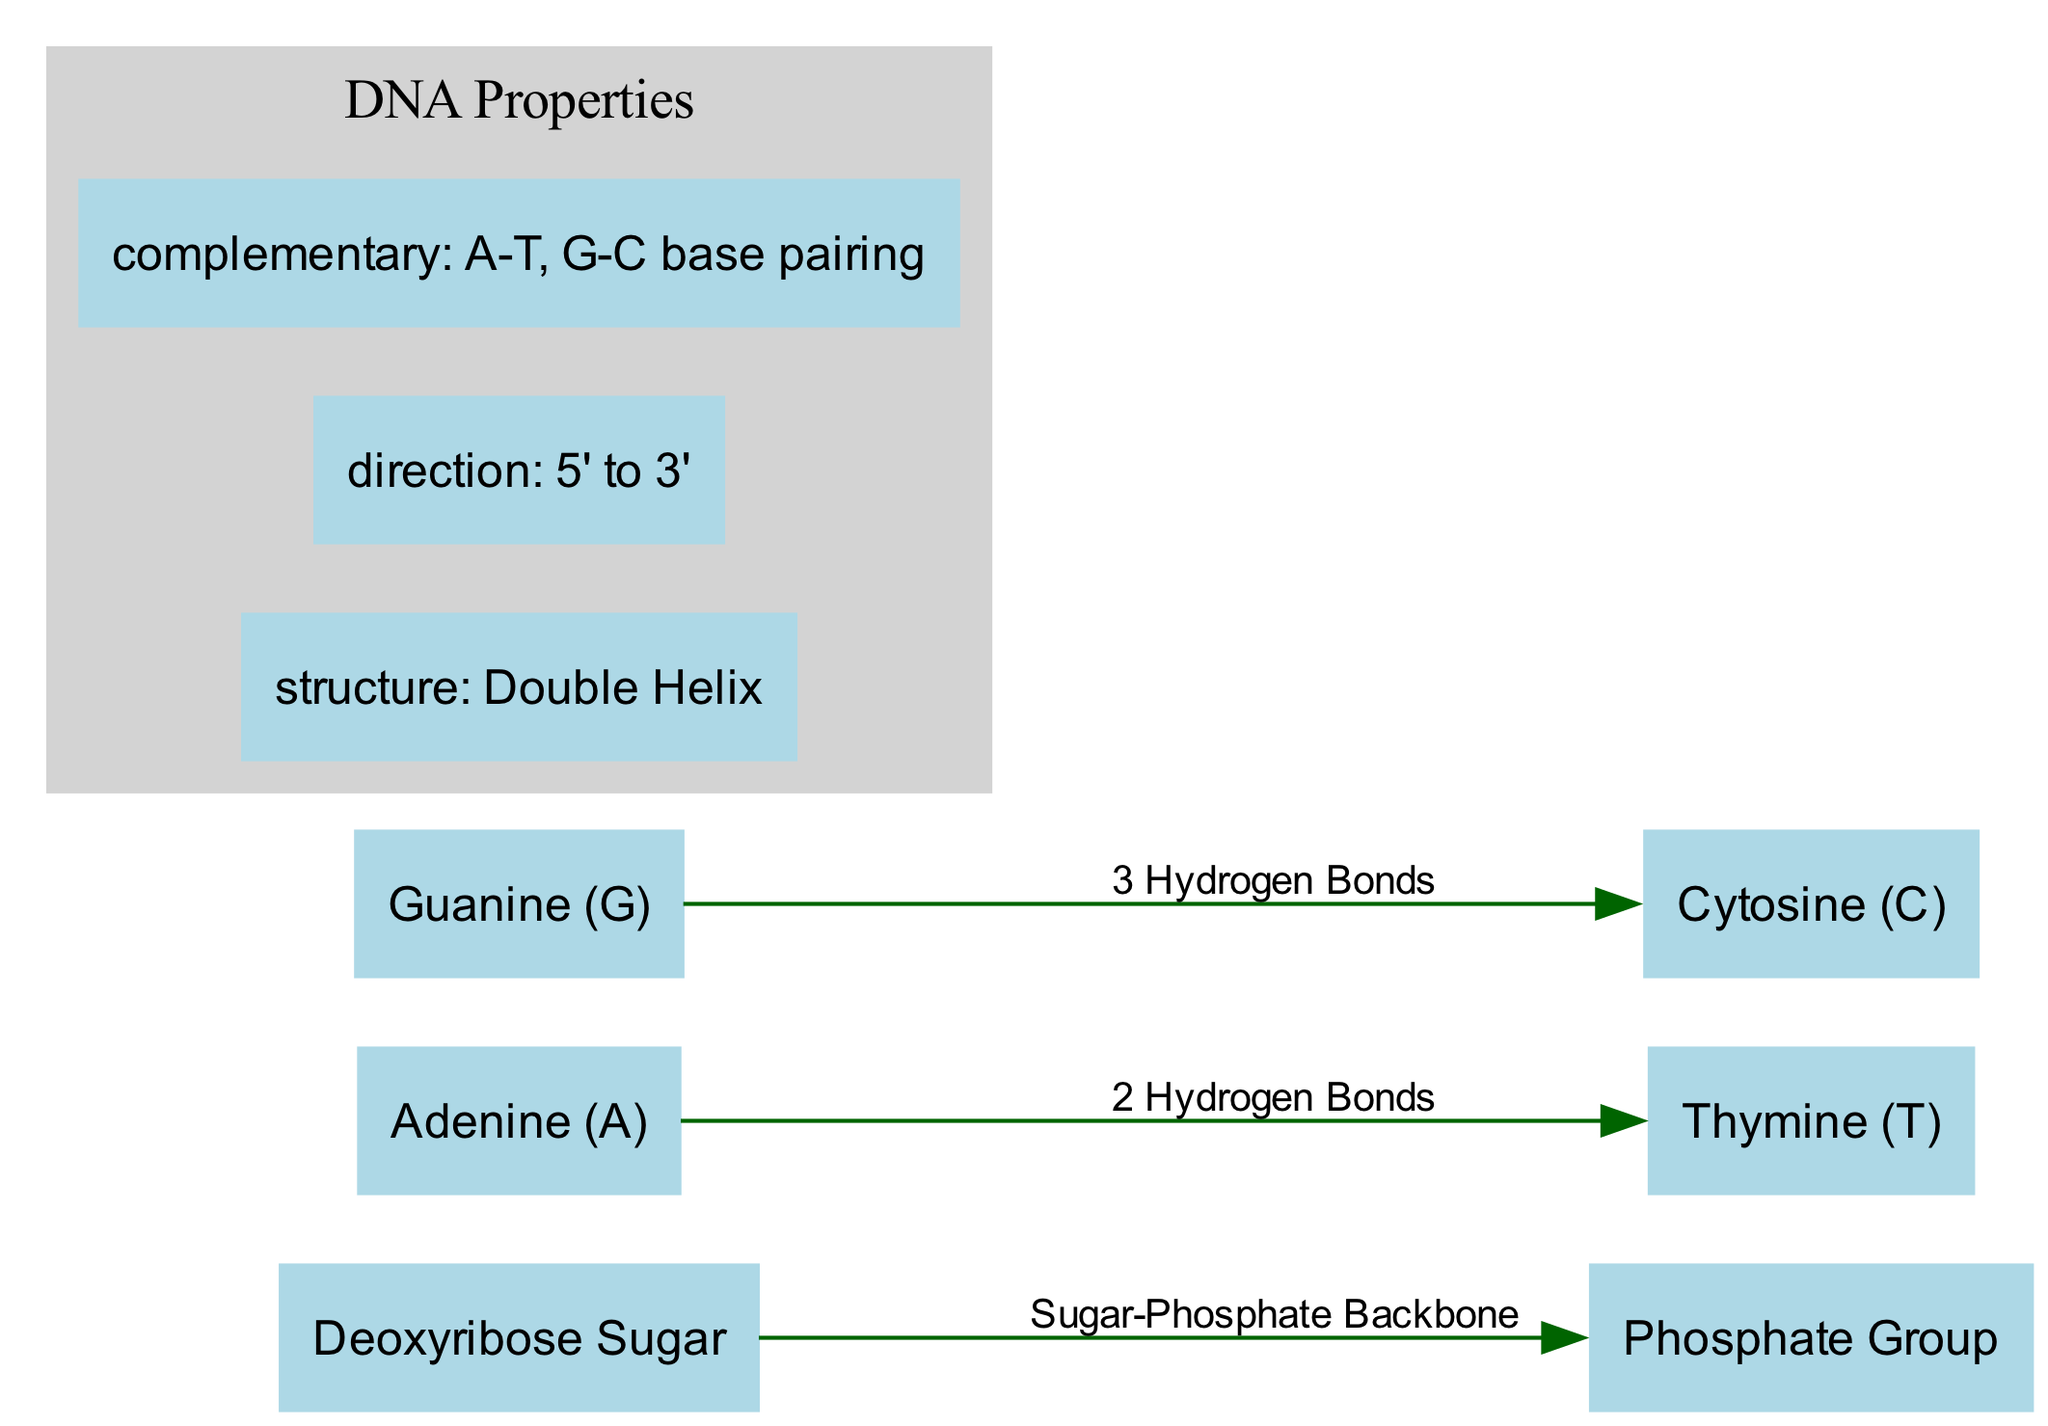What is the label of the node representing the base pair that contains adenine? The node representing the base pair that contains adenine is labeled "Adenine (A)". This information is directly obtained from the nodes section of the diagram data.
Answer: Adenine (A) How many nodes are present in the diagram? The diagram contains six distinct nodes, which include deoxyribose sugar, phosphate group, and the four nucleotide bases (adenine, thymine, guanine, cytosine). This count is derived from the nodes list.
Answer: 6 What type of bond occurs between adenine and thymine? The bond between adenine and thymine is labeled as "2 Hydrogen Bonds". This is specified in the edges section of the diagram where the relationship is illustrated.
Answer: 2 Hydrogen Bonds What is the directionality of the DNA double helix structure? The directionality of the DNA double helix structure is specified as "5' to 3'". This information is part of the properties section of the diagram data.
Answer: 5' to 3' Which nucleotide pairs with cytosine? Cytosine pairs with guanine in the diagram. This is evident from the edges section, which specifies the pairing relationship.
Answer: Guanine (G) How many hydrogen bonds are formed between guanine and cytosine? The number of hydrogen bonds formed between guanine and cytosine is "3 Hydrogen Bonds". This count is provided in the edges section outlining the bonds formed in base pairing.
Answer: 3 Hydrogen Bonds What is the label of the sugar in the DNA structure? The label of the sugar in the DNA structure is "Deoxyribose Sugar". This is directly taken from the node that specifies the sugar component in the DNA molecule.
Answer: Deoxyribose Sugar Describe the structure type of the DNA shown in the diagram. The diagram indicates the structure type as "Double Helix". This type is explicitly mentioned in the properties section of the diagram data.
Answer: Double Helix What forms the Sugar-Phosphate Backbone in the DNA structure? The Sugar-Phosphate Backbone is formed by the connection of the Deoxyribose Sugar and the Phosphate Group. This relationship is outlined explicitly as an edge in the diagram.
Answer: Deoxyribose Sugar and Phosphate Group 